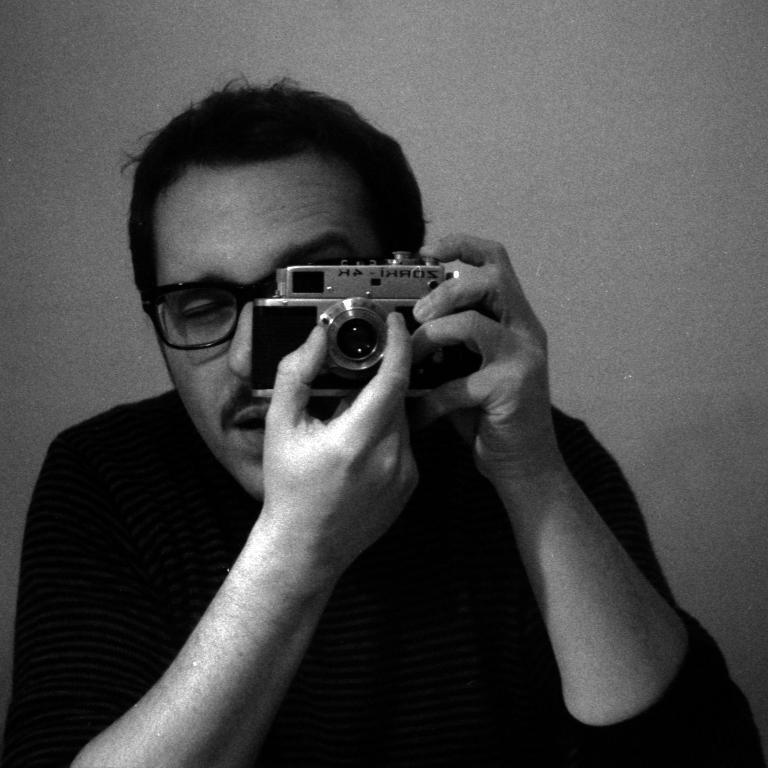In one or two sentences, can you explain what this image depicts? This is a black and white picture a man in a t shirt holding a camera and the man is adjusting something on the camera. Background of the man is a wall. 